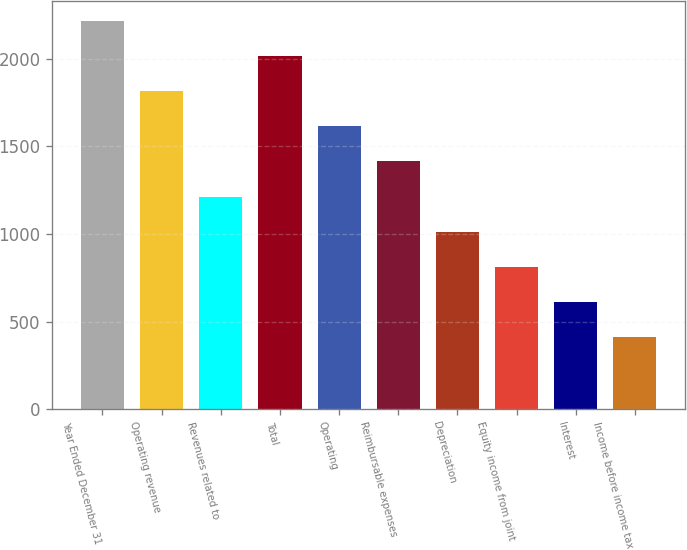Convert chart. <chart><loc_0><loc_0><loc_500><loc_500><bar_chart><fcel>Year Ended December 31<fcel>Operating revenue<fcel>Revenues related to<fcel>Total<fcel>Operating<fcel>Reimbursable expenses<fcel>Depreciation<fcel>Equity income from joint<fcel>Interest<fcel>Income before income tax<nl><fcel>2216.6<fcel>1815.4<fcel>1213.6<fcel>2016<fcel>1614.8<fcel>1414.2<fcel>1013<fcel>812.4<fcel>611.8<fcel>411.2<nl></chart> 